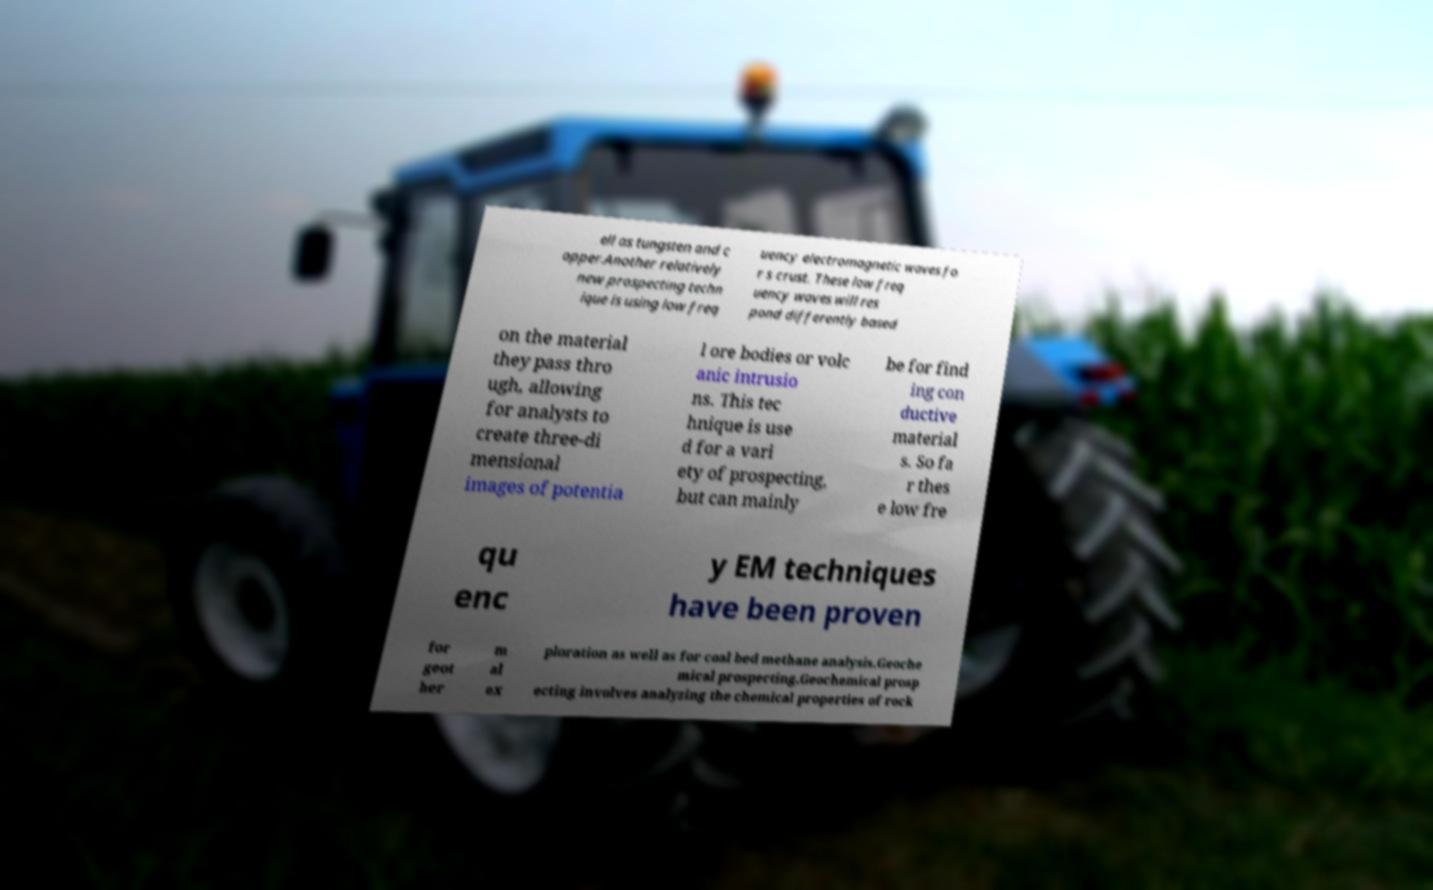Please identify and transcribe the text found in this image. ell as tungsten and c opper.Another relatively new prospecting techn ique is using low freq uency electromagnetic waves fo r s crust. These low freq uency waves will res pond differently based on the material they pass thro ugh, allowing for analysts to create three-di mensional images of potentia l ore bodies or volc anic intrusio ns. This tec hnique is use d for a vari ety of prospecting, but can mainly be for find ing con ductive material s. So fa r thes e low fre qu enc y EM techniques have been proven for geot her m al ex ploration as well as for coal bed methane analysis.Geoche mical prospecting.Geochemical prosp ecting involves analyzing the chemical properties of rock 